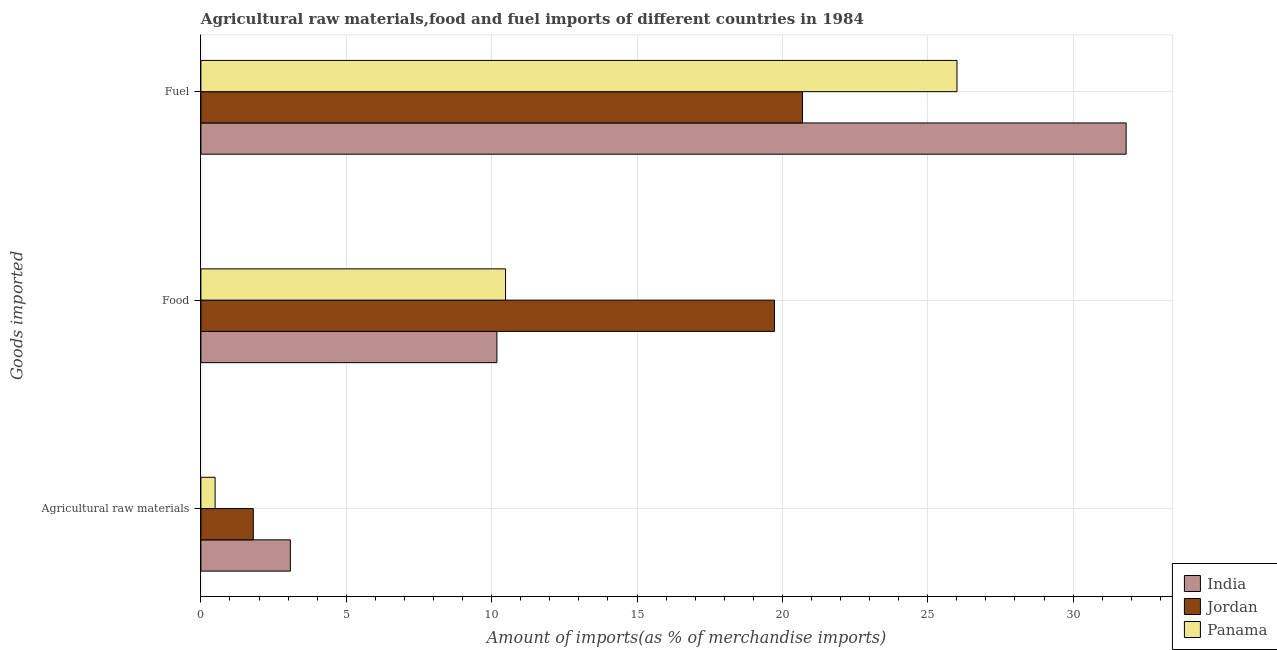How many different coloured bars are there?
Your response must be concise. 3. How many groups of bars are there?
Ensure brevity in your answer.  3. How many bars are there on the 1st tick from the top?
Keep it short and to the point. 3. What is the label of the 3rd group of bars from the top?
Your answer should be compact. Agricultural raw materials. What is the percentage of fuel imports in Jordan?
Ensure brevity in your answer.  20.69. Across all countries, what is the maximum percentage of food imports?
Give a very brief answer. 19.73. Across all countries, what is the minimum percentage of fuel imports?
Make the answer very short. 20.69. In which country was the percentage of raw materials imports minimum?
Keep it short and to the point. Panama. What is the total percentage of fuel imports in the graph?
Make the answer very short. 78.52. What is the difference between the percentage of food imports in India and that in Jordan?
Your response must be concise. -9.55. What is the difference between the percentage of food imports in Panama and the percentage of fuel imports in Jordan?
Your answer should be very brief. -10.21. What is the average percentage of fuel imports per country?
Provide a succinct answer. 26.17. What is the difference between the percentage of raw materials imports and percentage of food imports in Panama?
Offer a very short reply. -9.99. What is the ratio of the percentage of fuel imports in Jordan to that in India?
Give a very brief answer. 0.65. Is the percentage of fuel imports in India less than that in Panama?
Keep it short and to the point. No. Is the difference between the percentage of fuel imports in Jordan and Panama greater than the difference between the percentage of raw materials imports in Jordan and Panama?
Provide a short and direct response. No. What is the difference between the highest and the second highest percentage of fuel imports?
Provide a short and direct response. 5.82. What is the difference between the highest and the lowest percentage of fuel imports?
Provide a short and direct response. 11.13. In how many countries, is the percentage of fuel imports greater than the average percentage of fuel imports taken over all countries?
Give a very brief answer. 1. Is the sum of the percentage of fuel imports in Jordan and India greater than the maximum percentage of food imports across all countries?
Give a very brief answer. Yes. What does the 3rd bar from the bottom in Fuel represents?
Provide a short and direct response. Panama. What is the difference between two consecutive major ticks on the X-axis?
Your response must be concise. 5. Does the graph contain any zero values?
Give a very brief answer. No. Does the graph contain grids?
Your response must be concise. Yes. How many legend labels are there?
Provide a succinct answer. 3. How are the legend labels stacked?
Ensure brevity in your answer.  Vertical. What is the title of the graph?
Your response must be concise. Agricultural raw materials,food and fuel imports of different countries in 1984. What is the label or title of the X-axis?
Your response must be concise. Amount of imports(as % of merchandise imports). What is the label or title of the Y-axis?
Your answer should be compact. Goods imported. What is the Amount of imports(as % of merchandise imports) in India in Agricultural raw materials?
Offer a terse response. 3.08. What is the Amount of imports(as % of merchandise imports) of Jordan in Agricultural raw materials?
Make the answer very short. 1.8. What is the Amount of imports(as % of merchandise imports) of Panama in Agricultural raw materials?
Provide a short and direct response. 0.49. What is the Amount of imports(as % of merchandise imports) of India in Food?
Keep it short and to the point. 10.18. What is the Amount of imports(as % of merchandise imports) of Jordan in Food?
Offer a terse response. 19.73. What is the Amount of imports(as % of merchandise imports) of Panama in Food?
Offer a very short reply. 10.48. What is the Amount of imports(as % of merchandise imports) in India in Fuel?
Offer a terse response. 31.82. What is the Amount of imports(as % of merchandise imports) of Jordan in Fuel?
Your answer should be compact. 20.69. What is the Amount of imports(as % of merchandise imports) in Panama in Fuel?
Keep it short and to the point. 26.01. Across all Goods imported, what is the maximum Amount of imports(as % of merchandise imports) of India?
Offer a very short reply. 31.82. Across all Goods imported, what is the maximum Amount of imports(as % of merchandise imports) of Jordan?
Provide a short and direct response. 20.69. Across all Goods imported, what is the maximum Amount of imports(as % of merchandise imports) in Panama?
Your response must be concise. 26.01. Across all Goods imported, what is the minimum Amount of imports(as % of merchandise imports) of India?
Provide a succinct answer. 3.08. Across all Goods imported, what is the minimum Amount of imports(as % of merchandise imports) in Jordan?
Your answer should be compact. 1.8. Across all Goods imported, what is the minimum Amount of imports(as % of merchandise imports) in Panama?
Make the answer very short. 0.49. What is the total Amount of imports(as % of merchandise imports) of India in the graph?
Ensure brevity in your answer.  45.08. What is the total Amount of imports(as % of merchandise imports) of Jordan in the graph?
Provide a short and direct response. 42.22. What is the total Amount of imports(as % of merchandise imports) of Panama in the graph?
Your answer should be compact. 36.97. What is the difference between the Amount of imports(as % of merchandise imports) of India in Agricultural raw materials and that in Food?
Make the answer very short. -7.1. What is the difference between the Amount of imports(as % of merchandise imports) of Jordan in Agricultural raw materials and that in Food?
Provide a succinct answer. -17.93. What is the difference between the Amount of imports(as % of merchandise imports) in Panama in Agricultural raw materials and that in Food?
Your answer should be very brief. -9.99. What is the difference between the Amount of imports(as % of merchandise imports) of India in Agricultural raw materials and that in Fuel?
Provide a succinct answer. -28.75. What is the difference between the Amount of imports(as % of merchandise imports) in Jordan in Agricultural raw materials and that in Fuel?
Keep it short and to the point. -18.89. What is the difference between the Amount of imports(as % of merchandise imports) of Panama in Agricultural raw materials and that in Fuel?
Your answer should be very brief. -25.52. What is the difference between the Amount of imports(as % of merchandise imports) in India in Food and that in Fuel?
Provide a short and direct response. -21.64. What is the difference between the Amount of imports(as % of merchandise imports) in Jordan in Food and that in Fuel?
Offer a very short reply. -0.96. What is the difference between the Amount of imports(as % of merchandise imports) of Panama in Food and that in Fuel?
Provide a succinct answer. -15.53. What is the difference between the Amount of imports(as % of merchandise imports) of India in Agricultural raw materials and the Amount of imports(as % of merchandise imports) of Jordan in Food?
Offer a very short reply. -16.65. What is the difference between the Amount of imports(as % of merchandise imports) in India in Agricultural raw materials and the Amount of imports(as % of merchandise imports) in Panama in Food?
Give a very brief answer. -7.4. What is the difference between the Amount of imports(as % of merchandise imports) of Jordan in Agricultural raw materials and the Amount of imports(as % of merchandise imports) of Panama in Food?
Offer a very short reply. -8.68. What is the difference between the Amount of imports(as % of merchandise imports) in India in Agricultural raw materials and the Amount of imports(as % of merchandise imports) in Jordan in Fuel?
Your answer should be compact. -17.62. What is the difference between the Amount of imports(as % of merchandise imports) in India in Agricultural raw materials and the Amount of imports(as % of merchandise imports) in Panama in Fuel?
Provide a short and direct response. -22.93. What is the difference between the Amount of imports(as % of merchandise imports) of Jordan in Agricultural raw materials and the Amount of imports(as % of merchandise imports) of Panama in Fuel?
Give a very brief answer. -24.2. What is the difference between the Amount of imports(as % of merchandise imports) in India in Food and the Amount of imports(as % of merchandise imports) in Jordan in Fuel?
Offer a very short reply. -10.51. What is the difference between the Amount of imports(as % of merchandise imports) of India in Food and the Amount of imports(as % of merchandise imports) of Panama in Fuel?
Your response must be concise. -15.83. What is the difference between the Amount of imports(as % of merchandise imports) in Jordan in Food and the Amount of imports(as % of merchandise imports) in Panama in Fuel?
Provide a short and direct response. -6.28. What is the average Amount of imports(as % of merchandise imports) in India per Goods imported?
Give a very brief answer. 15.03. What is the average Amount of imports(as % of merchandise imports) of Jordan per Goods imported?
Provide a succinct answer. 14.07. What is the average Amount of imports(as % of merchandise imports) of Panama per Goods imported?
Provide a short and direct response. 12.32. What is the difference between the Amount of imports(as % of merchandise imports) of India and Amount of imports(as % of merchandise imports) of Jordan in Agricultural raw materials?
Give a very brief answer. 1.27. What is the difference between the Amount of imports(as % of merchandise imports) in India and Amount of imports(as % of merchandise imports) in Panama in Agricultural raw materials?
Offer a terse response. 2.59. What is the difference between the Amount of imports(as % of merchandise imports) of Jordan and Amount of imports(as % of merchandise imports) of Panama in Agricultural raw materials?
Your answer should be compact. 1.31. What is the difference between the Amount of imports(as % of merchandise imports) in India and Amount of imports(as % of merchandise imports) in Jordan in Food?
Provide a short and direct response. -9.55. What is the difference between the Amount of imports(as % of merchandise imports) of India and Amount of imports(as % of merchandise imports) of Panama in Food?
Give a very brief answer. -0.3. What is the difference between the Amount of imports(as % of merchandise imports) in Jordan and Amount of imports(as % of merchandise imports) in Panama in Food?
Offer a very short reply. 9.25. What is the difference between the Amount of imports(as % of merchandise imports) of India and Amount of imports(as % of merchandise imports) of Jordan in Fuel?
Offer a terse response. 11.13. What is the difference between the Amount of imports(as % of merchandise imports) in India and Amount of imports(as % of merchandise imports) in Panama in Fuel?
Make the answer very short. 5.82. What is the difference between the Amount of imports(as % of merchandise imports) in Jordan and Amount of imports(as % of merchandise imports) in Panama in Fuel?
Your answer should be very brief. -5.31. What is the ratio of the Amount of imports(as % of merchandise imports) of India in Agricultural raw materials to that in Food?
Make the answer very short. 0.3. What is the ratio of the Amount of imports(as % of merchandise imports) of Jordan in Agricultural raw materials to that in Food?
Offer a very short reply. 0.09. What is the ratio of the Amount of imports(as % of merchandise imports) in Panama in Agricultural raw materials to that in Food?
Provide a succinct answer. 0.05. What is the ratio of the Amount of imports(as % of merchandise imports) in India in Agricultural raw materials to that in Fuel?
Your answer should be very brief. 0.1. What is the ratio of the Amount of imports(as % of merchandise imports) of Jordan in Agricultural raw materials to that in Fuel?
Give a very brief answer. 0.09. What is the ratio of the Amount of imports(as % of merchandise imports) in Panama in Agricultural raw materials to that in Fuel?
Make the answer very short. 0.02. What is the ratio of the Amount of imports(as % of merchandise imports) in India in Food to that in Fuel?
Your answer should be compact. 0.32. What is the ratio of the Amount of imports(as % of merchandise imports) of Jordan in Food to that in Fuel?
Provide a short and direct response. 0.95. What is the ratio of the Amount of imports(as % of merchandise imports) in Panama in Food to that in Fuel?
Make the answer very short. 0.4. What is the difference between the highest and the second highest Amount of imports(as % of merchandise imports) of India?
Your answer should be compact. 21.64. What is the difference between the highest and the second highest Amount of imports(as % of merchandise imports) in Jordan?
Offer a terse response. 0.96. What is the difference between the highest and the second highest Amount of imports(as % of merchandise imports) in Panama?
Your answer should be very brief. 15.53. What is the difference between the highest and the lowest Amount of imports(as % of merchandise imports) of India?
Your answer should be very brief. 28.75. What is the difference between the highest and the lowest Amount of imports(as % of merchandise imports) of Jordan?
Your response must be concise. 18.89. What is the difference between the highest and the lowest Amount of imports(as % of merchandise imports) of Panama?
Ensure brevity in your answer.  25.52. 